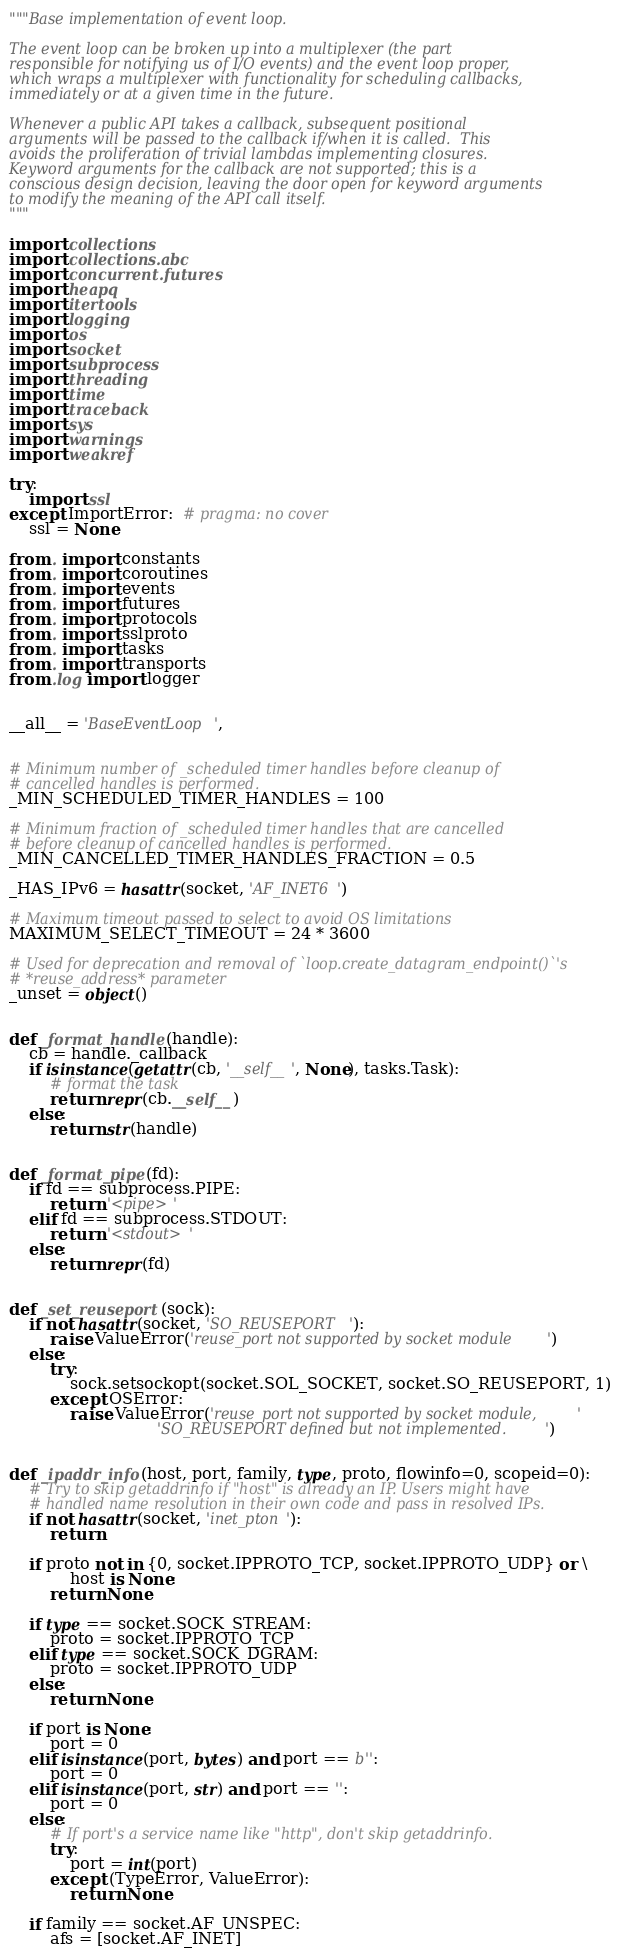Convert code to text. <code><loc_0><loc_0><loc_500><loc_500><_Python_>"""Base implementation of event loop.

The event loop can be broken up into a multiplexer (the part
responsible for notifying us of I/O events) and the event loop proper,
which wraps a multiplexer with functionality for scheduling callbacks,
immediately or at a given time in the future.

Whenever a public API takes a callback, subsequent positional
arguments will be passed to the callback if/when it is called.  This
avoids the proliferation of trivial lambdas implementing closures.
Keyword arguments for the callback are not supported; this is a
conscious design decision, leaving the door open for keyword arguments
to modify the meaning of the API call itself.
"""

import collections
import collections.abc
import concurrent.futures
import heapq
import itertools
import logging
import os
import socket
import subprocess
import threading
import time
import traceback
import sys
import warnings
import weakref

try:
    import ssl
except ImportError:  # pragma: no cover
    ssl = None

from . import constants
from . import coroutines
from . import events
from . import futures
from . import protocols
from . import sslproto
from . import tasks
from . import transports
from .log import logger


__all__ = 'BaseEventLoop',


# Minimum number of _scheduled timer handles before cleanup of
# cancelled handles is performed.
_MIN_SCHEDULED_TIMER_HANDLES = 100

# Minimum fraction of _scheduled timer handles that are cancelled
# before cleanup of cancelled handles is performed.
_MIN_CANCELLED_TIMER_HANDLES_FRACTION = 0.5

_HAS_IPv6 = hasattr(socket, 'AF_INET6')

# Maximum timeout passed to select to avoid OS limitations
MAXIMUM_SELECT_TIMEOUT = 24 * 3600

# Used for deprecation and removal of `loop.create_datagram_endpoint()`'s
# *reuse_address* parameter
_unset = object()


def _format_handle(handle):
    cb = handle._callback
    if isinstance(getattr(cb, '__self__', None), tasks.Task):
        # format the task
        return repr(cb.__self__)
    else:
        return str(handle)


def _format_pipe(fd):
    if fd == subprocess.PIPE:
        return '<pipe>'
    elif fd == subprocess.STDOUT:
        return '<stdout>'
    else:
        return repr(fd)


def _set_reuseport(sock):
    if not hasattr(socket, 'SO_REUSEPORT'):
        raise ValueError('reuse_port not supported by socket module')
    else:
        try:
            sock.setsockopt(socket.SOL_SOCKET, socket.SO_REUSEPORT, 1)
        except OSError:
            raise ValueError('reuse_port not supported by socket module, '
                             'SO_REUSEPORT defined but not implemented.')


def _ipaddr_info(host, port, family, type, proto, flowinfo=0, scopeid=0):
    # Try to skip getaddrinfo if "host" is already an IP. Users might have
    # handled name resolution in their own code and pass in resolved IPs.
    if not hasattr(socket, 'inet_pton'):
        return

    if proto not in {0, socket.IPPROTO_TCP, socket.IPPROTO_UDP} or \
            host is None:
        return None

    if type == socket.SOCK_STREAM:
        proto = socket.IPPROTO_TCP
    elif type == socket.SOCK_DGRAM:
        proto = socket.IPPROTO_UDP
    else:
        return None

    if port is None:
        port = 0
    elif isinstance(port, bytes) and port == b'':
        port = 0
    elif isinstance(port, str) and port == '':
        port = 0
    else:
        # If port's a service name like "http", don't skip getaddrinfo.
        try:
            port = int(port)
        except (TypeError, ValueError):
            return None

    if family == socket.AF_UNSPEC:
        afs = [socket.AF_INET]</code> 